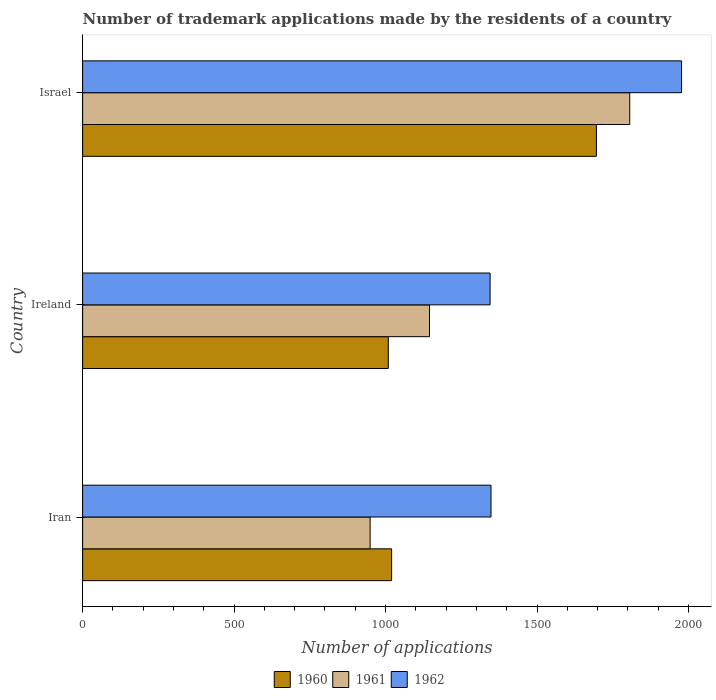How many different coloured bars are there?
Provide a succinct answer. 3. How many groups of bars are there?
Keep it short and to the point. 3. How many bars are there on the 2nd tick from the bottom?
Offer a terse response. 3. What is the label of the 3rd group of bars from the top?
Your answer should be very brief. Iran. What is the number of trademark applications made by the residents in 1962 in Iran?
Your answer should be very brief. 1348. Across all countries, what is the maximum number of trademark applications made by the residents in 1960?
Offer a very short reply. 1696. Across all countries, what is the minimum number of trademark applications made by the residents in 1961?
Give a very brief answer. 949. In which country was the number of trademark applications made by the residents in 1960 minimum?
Your answer should be very brief. Ireland. What is the total number of trademark applications made by the residents in 1961 in the graph?
Keep it short and to the point. 3900. What is the difference between the number of trademark applications made by the residents in 1962 in Iran and that in Israel?
Keep it short and to the point. -629. What is the average number of trademark applications made by the residents in 1961 per country?
Ensure brevity in your answer.  1300. What is the difference between the number of trademark applications made by the residents in 1960 and number of trademark applications made by the residents in 1962 in Iran?
Provide a succinct answer. -328. What is the ratio of the number of trademark applications made by the residents in 1962 in Iran to that in Ireland?
Provide a short and direct response. 1. What is the difference between the highest and the second highest number of trademark applications made by the residents in 1961?
Your answer should be compact. 661. What is the difference between the highest and the lowest number of trademark applications made by the residents in 1961?
Give a very brief answer. 857. Is the sum of the number of trademark applications made by the residents in 1960 in Iran and Israel greater than the maximum number of trademark applications made by the residents in 1961 across all countries?
Your answer should be very brief. Yes. What does the 1st bar from the top in Israel represents?
Give a very brief answer. 1962. What does the 2nd bar from the bottom in Ireland represents?
Your response must be concise. 1961. Is it the case that in every country, the sum of the number of trademark applications made by the residents in 1960 and number of trademark applications made by the residents in 1961 is greater than the number of trademark applications made by the residents in 1962?
Keep it short and to the point. Yes. How many countries are there in the graph?
Offer a very short reply. 3. What is the difference between two consecutive major ticks on the X-axis?
Provide a short and direct response. 500. Are the values on the major ticks of X-axis written in scientific E-notation?
Offer a terse response. No. Does the graph contain any zero values?
Provide a succinct answer. No. Does the graph contain grids?
Provide a short and direct response. No. What is the title of the graph?
Offer a very short reply. Number of trademark applications made by the residents of a country. Does "2008" appear as one of the legend labels in the graph?
Provide a short and direct response. No. What is the label or title of the X-axis?
Your answer should be compact. Number of applications. What is the label or title of the Y-axis?
Keep it short and to the point. Country. What is the Number of applications of 1960 in Iran?
Provide a succinct answer. 1020. What is the Number of applications in 1961 in Iran?
Your answer should be very brief. 949. What is the Number of applications in 1962 in Iran?
Ensure brevity in your answer.  1348. What is the Number of applications in 1960 in Ireland?
Your answer should be very brief. 1009. What is the Number of applications of 1961 in Ireland?
Provide a short and direct response. 1145. What is the Number of applications of 1962 in Ireland?
Offer a very short reply. 1345. What is the Number of applications in 1960 in Israel?
Your answer should be compact. 1696. What is the Number of applications in 1961 in Israel?
Provide a succinct answer. 1806. What is the Number of applications of 1962 in Israel?
Make the answer very short. 1977. Across all countries, what is the maximum Number of applications of 1960?
Provide a succinct answer. 1696. Across all countries, what is the maximum Number of applications in 1961?
Your response must be concise. 1806. Across all countries, what is the maximum Number of applications in 1962?
Your answer should be compact. 1977. Across all countries, what is the minimum Number of applications of 1960?
Ensure brevity in your answer.  1009. Across all countries, what is the minimum Number of applications of 1961?
Your answer should be compact. 949. Across all countries, what is the minimum Number of applications of 1962?
Offer a terse response. 1345. What is the total Number of applications in 1960 in the graph?
Offer a very short reply. 3725. What is the total Number of applications in 1961 in the graph?
Give a very brief answer. 3900. What is the total Number of applications of 1962 in the graph?
Your answer should be compact. 4670. What is the difference between the Number of applications in 1961 in Iran and that in Ireland?
Provide a short and direct response. -196. What is the difference between the Number of applications in 1960 in Iran and that in Israel?
Keep it short and to the point. -676. What is the difference between the Number of applications of 1961 in Iran and that in Israel?
Offer a very short reply. -857. What is the difference between the Number of applications of 1962 in Iran and that in Israel?
Ensure brevity in your answer.  -629. What is the difference between the Number of applications of 1960 in Ireland and that in Israel?
Provide a short and direct response. -687. What is the difference between the Number of applications in 1961 in Ireland and that in Israel?
Offer a very short reply. -661. What is the difference between the Number of applications in 1962 in Ireland and that in Israel?
Keep it short and to the point. -632. What is the difference between the Number of applications in 1960 in Iran and the Number of applications in 1961 in Ireland?
Your answer should be very brief. -125. What is the difference between the Number of applications of 1960 in Iran and the Number of applications of 1962 in Ireland?
Make the answer very short. -325. What is the difference between the Number of applications in 1961 in Iran and the Number of applications in 1962 in Ireland?
Offer a very short reply. -396. What is the difference between the Number of applications in 1960 in Iran and the Number of applications in 1961 in Israel?
Offer a terse response. -786. What is the difference between the Number of applications in 1960 in Iran and the Number of applications in 1962 in Israel?
Ensure brevity in your answer.  -957. What is the difference between the Number of applications of 1961 in Iran and the Number of applications of 1962 in Israel?
Give a very brief answer. -1028. What is the difference between the Number of applications of 1960 in Ireland and the Number of applications of 1961 in Israel?
Make the answer very short. -797. What is the difference between the Number of applications in 1960 in Ireland and the Number of applications in 1962 in Israel?
Make the answer very short. -968. What is the difference between the Number of applications of 1961 in Ireland and the Number of applications of 1962 in Israel?
Give a very brief answer. -832. What is the average Number of applications of 1960 per country?
Ensure brevity in your answer.  1241.67. What is the average Number of applications in 1961 per country?
Keep it short and to the point. 1300. What is the average Number of applications in 1962 per country?
Give a very brief answer. 1556.67. What is the difference between the Number of applications in 1960 and Number of applications in 1961 in Iran?
Provide a succinct answer. 71. What is the difference between the Number of applications of 1960 and Number of applications of 1962 in Iran?
Provide a succinct answer. -328. What is the difference between the Number of applications in 1961 and Number of applications in 1962 in Iran?
Ensure brevity in your answer.  -399. What is the difference between the Number of applications in 1960 and Number of applications in 1961 in Ireland?
Provide a short and direct response. -136. What is the difference between the Number of applications of 1960 and Number of applications of 1962 in Ireland?
Provide a succinct answer. -336. What is the difference between the Number of applications of 1961 and Number of applications of 1962 in Ireland?
Provide a short and direct response. -200. What is the difference between the Number of applications of 1960 and Number of applications of 1961 in Israel?
Make the answer very short. -110. What is the difference between the Number of applications of 1960 and Number of applications of 1962 in Israel?
Keep it short and to the point. -281. What is the difference between the Number of applications in 1961 and Number of applications in 1962 in Israel?
Provide a short and direct response. -171. What is the ratio of the Number of applications of 1960 in Iran to that in Ireland?
Ensure brevity in your answer.  1.01. What is the ratio of the Number of applications of 1961 in Iran to that in Ireland?
Ensure brevity in your answer.  0.83. What is the ratio of the Number of applications of 1962 in Iran to that in Ireland?
Your answer should be very brief. 1. What is the ratio of the Number of applications of 1960 in Iran to that in Israel?
Your answer should be compact. 0.6. What is the ratio of the Number of applications in 1961 in Iran to that in Israel?
Your answer should be compact. 0.53. What is the ratio of the Number of applications of 1962 in Iran to that in Israel?
Give a very brief answer. 0.68. What is the ratio of the Number of applications in 1960 in Ireland to that in Israel?
Offer a very short reply. 0.59. What is the ratio of the Number of applications in 1961 in Ireland to that in Israel?
Offer a terse response. 0.63. What is the ratio of the Number of applications of 1962 in Ireland to that in Israel?
Keep it short and to the point. 0.68. What is the difference between the highest and the second highest Number of applications in 1960?
Give a very brief answer. 676. What is the difference between the highest and the second highest Number of applications of 1961?
Your answer should be very brief. 661. What is the difference between the highest and the second highest Number of applications in 1962?
Offer a terse response. 629. What is the difference between the highest and the lowest Number of applications of 1960?
Your answer should be compact. 687. What is the difference between the highest and the lowest Number of applications of 1961?
Your answer should be very brief. 857. What is the difference between the highest and the lowest Number of applications of 1962?
Offer a very short reply. 632. 